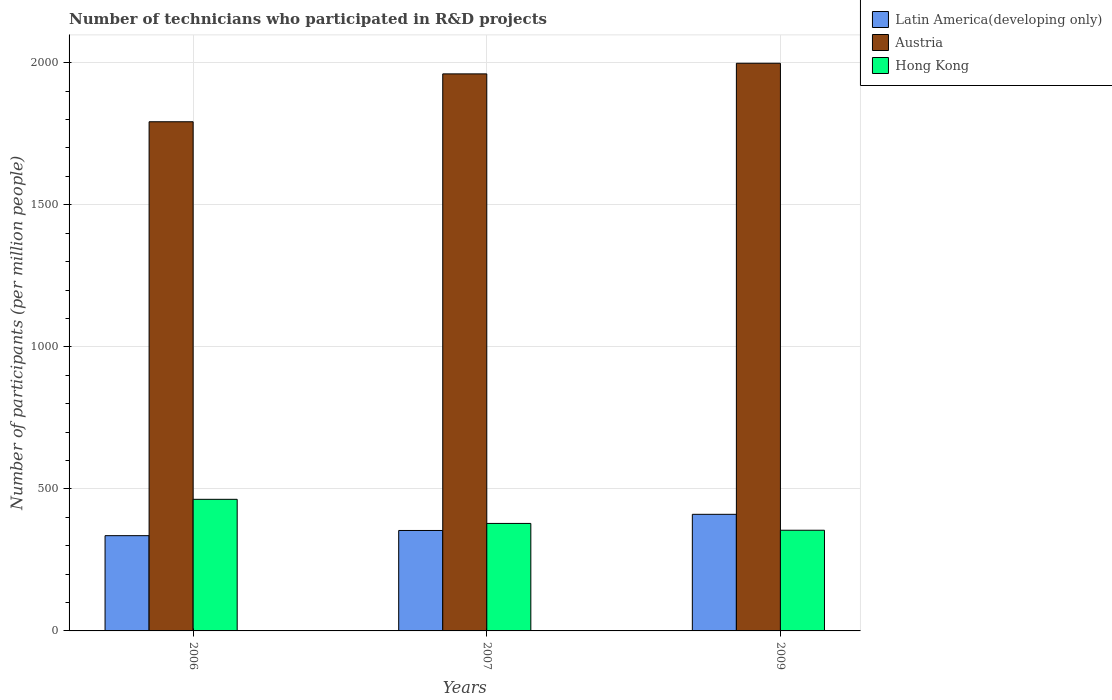How many different coloured bars are there?
Give a very brief answer. 3. How many groups of bars are there?
Offer a very short reply. 3. How many bars are there on the 3rd tick from the right?
Offer a terse response. 3. What is the label of the 3rd group of bars from the left?
Provide a succinct answer. 2009. In how many cases, is the number of bars for a given year not equal to the number of legend labels?
Your response must be concise. 0. What is the number of technicians who participated in R&D projects in Austria in 2006?
Keep it short and to the point. 1792.36. Across all years, what is the maximum number of technicians who participated in R&D projects in Austria?
Provide a short and direct response. 1998.31. Across all years, what is the minimum number of technicians who participated in R&D projects in Hong Kong?
Ensure brevity in your answer.  354.43. What is the total number of technicians who participated in R&D projects in Austria in the graph?
Keep it short and to the point. 5751.56. What is the difference between the number of technicians who participated in R&D projects in Austria in 2006 and that in 2007?
Keep it short and to the point. -168.53. What is the difference between the number of technicians who participated in R&D projects in Austria in 2009 and the number of technicians who participated in R&D projects in Hong Kong in 2006?
Your answer should be compact. 1535.05. What is the average number of technicians who participated in R&D projects in Hong Kong per year?
Your response must be concise. 398.7. In the year 2007, what is the difference between the number of technicians who participated in R&D projects in Hong Kong and number of technicians who participated in R&D projects in Latin America(developing only)?
Ensure brevity in your answer.  24.83. What is the ratio of the number of technicians who participated in R&D projects in Hong Kong in 2006 to that in 2007?
Make the answer very short. 1.22. Is the number of technicians who participated in R&D projects in Hong Kong in 2007 less than that in 2009?
Ensure brevity in your answer.  No. Is the difference between the number of technicians who participated in R&D projects in Hong Kong in 2007 and 2009 greater than the difference between the number of technicians who participated in R&D projects in Latin America(developing only) in 2007 and 2009?
Keep it short and to the point. Yes. What is the difference between the highest and the second highest number of technicians who participated in R&D projects in Hong Kong?
Offer a very short reply. 84.83. What is the difference between the highest and the lowest number of technicians who participated in R&D projects in Latin America(developing only)?
Ensure brevity in your answer.  75.13. Is the sum of the number of technicians who participated in R&D projects in Latin America(developing only) in 2007 and 2009 greater than the maximum number of technicians who participated in R&D projects in Hong Kong across all years?
Provide a succinct answer. Yes. What does the 3rd bar from the left in 2009 represents?
Give a very brief answer. Hong Kong. What does the 3rd bar from the right in 2007 represents?
Provide a succinct answer. Latin America(developing only). Is it the case that in every year, the sum of the number of technicians who participated in R&D projects in Austria and number of technicians who participated in R&D projects in Latin America(developing only) is greater than the number of technicians who participated in R&D projects in Hong Kong?
Offer a terse response. Yes. How many bars are there?
Keep it short and to the point. 9. Are all the bars in the graph horizontal?
Keep it short and to the point. No. Are the values on the major ticks of Y-axis written in scientific E-notation?
Provide a succinct answer. No. Does the graph contain any zero values?
Offer a very short reply. No. Does the graph contain grids?
Keep it short and to the point. Yes. How many legend labels are there?
Make the answer very short. 3. How are the legend labels stacked?
Provide a succinct answer. Vertical. What is the title of the graph?
Provide a short and direct response. Number of technicians who participated in R&D projects. What is the label or title of the Y-axis?
Give a very brief answer. Number of participants (per million people). What is the Number of participants (per million people) in Latin America(developing only) in 2006?
Make the answer very short. 335.31. What is the Number of participants (per million people) in Austria in 2006?
Give a very brief answer. 1792.36. What is the Number of participants (per million people) in Hong Kong in 2006?
Provide a succinct answer. 463.26. What is the Number of participants (per million people) in Latin America(developing only) in 2007?
Keep it short and to the point. 353.59. What is the Number of participants (per million people) of Austria in 2007?
Give a very brief answer. 1960.89. What is the Number of participants (per million people) in Hong Kong in 2007?
Offer a terse response. 378.42. What is the Number of participants (per million people) in Latin America(developing only) in 2009?
Give a very brief answer. 410.44. What is the Number of participants (per million people) of Austria in 2009?
Offer a very short reply. 1998.31. What is the Number of participants (per million people) of Hong Kong in 2009?
Keep it short and to the point. 354.43. Across all years, what is the maximum Number of participants (per million people) of Latin America(developing only)?
Your answer should be compact. 410.44. Across all years, what is the maximum Number of participants (per million people) in Austria?
Your answer should be compact. 1998.31. Across all years, what is the maximum Number of participants (per million people) in Hong Kong?
Ensure brevity in your answer.  463.26. Across all years, what is the minimum Number of participants (per million people) in Latin America(developing only)?
Provide a short and direct response. 335.31. Across all years, what is the minimum Number of participants (per million people) of Austria?
Your response must be concise. 1792.36. Across all years, what is the minimum Number of participants (per million people) of Hong Kong?
Your response must be concise. 354.43. What is the total Number of participants (per million people) of Latin America(developing only) in the graph?
Ensure brevity in your answer.  1099.34. What is the total Number of participants (per million people) in Austria in the graph?
Your answer should be very brief. 5751.56. What is the total Number of participants (per million people) of Hong Kong in the graph?
Provide a succinct answer. 1196.1. What is the difference between the Number of participants (per million people) in Latin America(developing only) in 2006 and that in 2007?
Offer a very short reply. -18.28. What is the difference between the Number of participants (per million people) in Austria in 2006 and that in 2007?
Your answer should be compact. -168.53. What is the difference between the Number of participants (per million people) in Hong Kong in 2006 and that in 2007?
Ensure brevity in your answer.  84.83. What is the difference between the Number of participants (per million people) of Latin America(developing only) in 2006 and that in 2009?
Your answer should be compact. -75.13. What is the difference between the Number of participants (per million people) of Austria in 2006 and that in 2009?
Offer a terse response. -205.95. What is the difference between the Number of participants (per million people) of Hong Kong in 2006 and that in 2009?
Give a very brief answer. 108.83. What is the difference between the Number of participants (per million people) in Latin America(developing only) in 2007 and that in 2009?
Give a very brief answer. -56.85. What is the difference between the Number of participants (per million people) of Austria in 2007 and that in 2009?
Provide a short and direct response. -37.42. What is the difference between the Number of participants (per million people) in Hong Kong in 2007 and that in 2009?
Give a very brief answer. 24. What is the difference between the Number of participants (per million people) of Latin America(developing only) in 2006 and the Number of participants (per million people) of Austria in 2007?
Ensure brevity in your answer.  -1625.58. What is the difference between the Number of participants (per million people) in Latin America(developing only) in 2006 and the Number of participants (per million people) in Hong Kong in 2007?
Keep it short and to the point. -43.11. What is the difference between the Number of participants (per million people) in Austria in 2006 and the Number of participants (per million people) in Hong Kong in 2007?
Provide a short and direct response. 1413.94. What is the difference between the Number of participants (per million people) in Latin America(developing only) in 2006 and the Number of participants (per million people) in Austria in 2009?
Offer a terse response. -1663. What is the difference between the Number of participants (per million people) of Latin America(developing only) in 2006 and the Number of participants (per million people) of Hong Kong in 2009?
Give a very brief answer. -19.11. What is the difference between the Number of participants (per million people) of Austria in 2006 and the Number of participants (per million people) of Hong Kong in 2009?
Your answer should be very brief. 1437.94. What is the difference between the Number of participants (per million people) in Latin America(developing only) in 2007 and the Number of participants (per million people) in Austria in 2009?
Give a very brief answer. -1644.72. What is the difference between the Number of participants (per million people) in Latin America(developing only) in 2007 and the Number of participants (per million people) in Hong Kong in 2009?
Offer a terse response. -0.84. What is the difference between the Number of participants (per million people) in Austria in 2007 and the Number of participants (per million people) in Hong Kong in 2009?
Keep it short and to the point. 1606.46. What is the average Number of participants (per million people) of Latin America(developing only) per year?
Make the answer very short. 366.45. What is the average Number of participants (per million people) of Austria per year?
Offer a very short reply. 1917.19. What is the average Number of participants (per million people) of Hong Kong per year?
Keep it short and to the point. 398.7. In the year 2006, what is the difference between the Number of participants (per million people) in Latin America(developing only) and Number of participants (per million people) in Austria?
Give a very brief answer. -1457.05. In the year 2006, what is the difference between the Number of participants (per million people) of Latin America(developing only) and Number of participants (per million people) of Hong Kong?
Offer a terse response. -127.94. In the year 2006, what is the difference between the Number of participants (per million people) in Austria and Number of participants (per million people) in Hong Kong?
Your answer should be very brief. 1329.1. In the year 2007, what is the difference between the Number of participants (per million people) of Latin America(developing only) and Number of participants (per million people) of Austria?
Your answer should be compact. -1607.3. In the year 2007, what is the difference between the Number of participants (per million people) of Latin America(developing only) and Number of participants (per million people) of Hong Kong?
Keep it short and to the point. -24.84. In the year 2007, what is the difference between the Number of participants (per million people) in Austria and Number of participants (per million people) in Hong Kong?
Offer a very short reply. 1582.47. In the year 2009, what is the difference between the Number of participants (per million people) in Latin America(developing only) and Number of participants (per million people) in Austria?
Provide a succinct answer. -1587.87. In the year 2009, what is the difference between the Number of participants (per million people) of Latin America(developing only) and Number of participants (per million people) of Hong Kong?
Provide a succinct answer. 56.02. In the year 2009, what is the difference between the Number of participants (per million people) of Austria and Number of participants (per million people) of Hong Kong?
Keep it short and to the point. 1643.89. What is the ratio of the Number of participants (per million people) of Latin America(developing only) in 2006 to that in 2007?
Your answer should be compact. 0.95. What is the ratio of the Number of participants (per million people) of Austria in 2006 to that in 2007?
Provide a short and direct response. 0.91. What is the ratio of the Number of participants (per million people) in Hong Kong in 2006 to that in 2007?
Keep it short and to the point. 1.22. What is the ratio of the Number of participants (per million people) in Latin America(developing only) in 2006 to that in 2009?
Ensure brevity in your answer.  0.82. What is the ratio of the Number of participants (per million people) in Austria in 2006 to that in 2009?
Provide a succinct answer. 0.9. What is the ratio of the Number of participants (per million people) in Hong Kong in 2006 to that in 2009?
Your response must be concise. 1.31. What is the ratio of the Number of participants (per million people) in Latin America(developing only) in 2007 to that in 2009?
Provide a succinct answer. 0.86. What is the ratio of the Number of participants (per million people) of Austria in 2007 to that in 2009?
Give a very brief answer. 0.98. What is the ratio of the Number of participants (per million people) of Hong Kong in 2007 to that in 2009?
Offer a terse response. 1.07. What is the difference between the highest and the second highest Number of participants (per million people) of Latin America(developing only)?
Your answer should be compact. 56.85. What is the difference between the highest and the second highest Number of participants (per million people) in Austria?
Your answer should be very brief. 37.42. What is the difference between the highest and the second highest Number of participants (per million people) of Hong Kong?
Provide a short and direct response. 84.83. What is the difference between the highest and the lowest Number of participants (per million people) of Latin America(developing only)?
Your answer should be compact. 75.13. What is the difference between the highest and the lowest Number of participants (per million people) of Austria?
Provide a succinct answer. 205.95. What is the difference between the highest and the lowest Number of participants (per million people) of Hong Kong?
Provide a succinct answer. 108.83. 